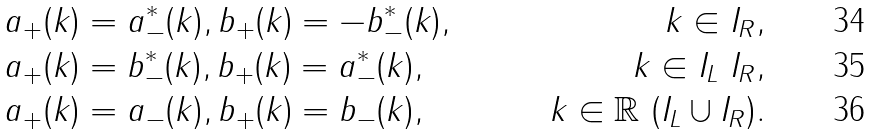<formula> <loc_0><loc_0><loc_500><loc_500>& a _ { + } ( k ) = a ^ { * } _ { - } ( k ) , b _ { + } ( k ) = - b ^ { * } _ { - } ( k ) , & k \in I _ { R } , \\ & a _ { + } ( k ) = b _ { - } ^ { * } ( k ) , b _ { + } ( k ) = a ^ { * } _ { - } ( k ) , & k \in I _ { L } \ I _ { R } , \\ & a _ { + } ( k ) = a _ { - } ( k ) , b _ { + } ( k ) = b _ { - } ( k ) , & k \in \mathbb { R } \ ( I _ { L } \cup I _ { R } ) .</formula> 